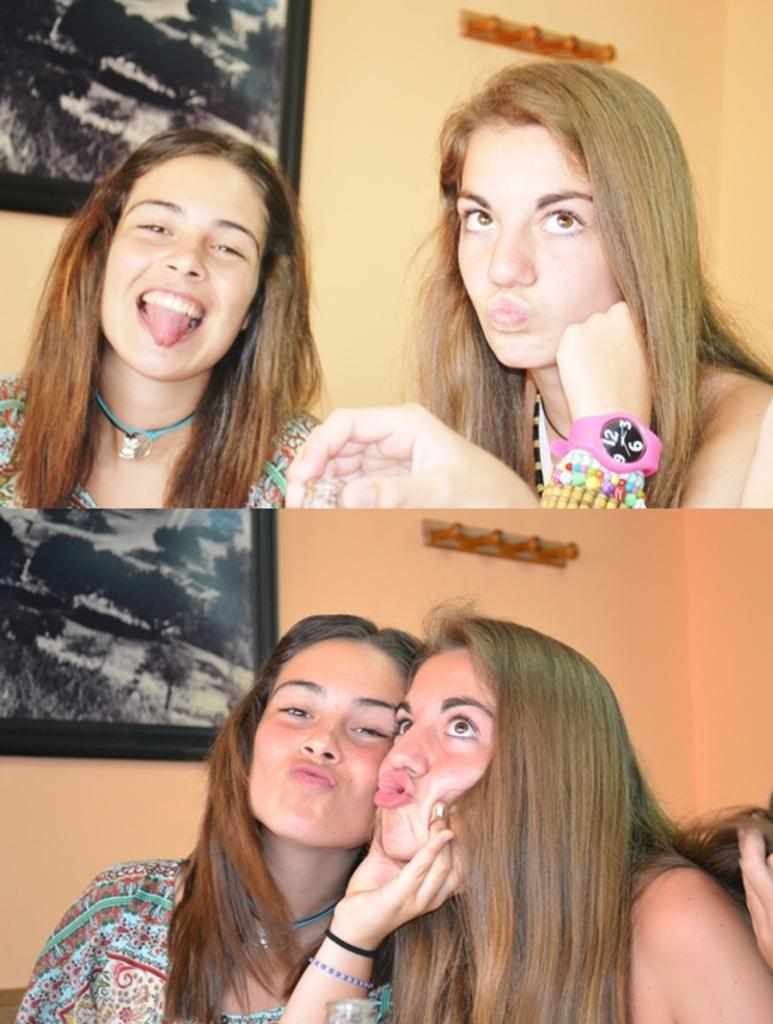How many women are in the image? There are two women in the image. Where is the first woman located in the image? The first woman is on the left side of the image. What is the facial expression of the woman on the left side? The woman on the left side is smiling. Can you describe any objects on the wall in the image? There is a photo frame on the wall in the image. What type of coil is being used by the giraffe in the image? There is no giraffe or coil present in the image. How can we help the woman on the right side of the image? The image does not provide any information about the woman on the right side needing help, nor does it show any way to help her. 